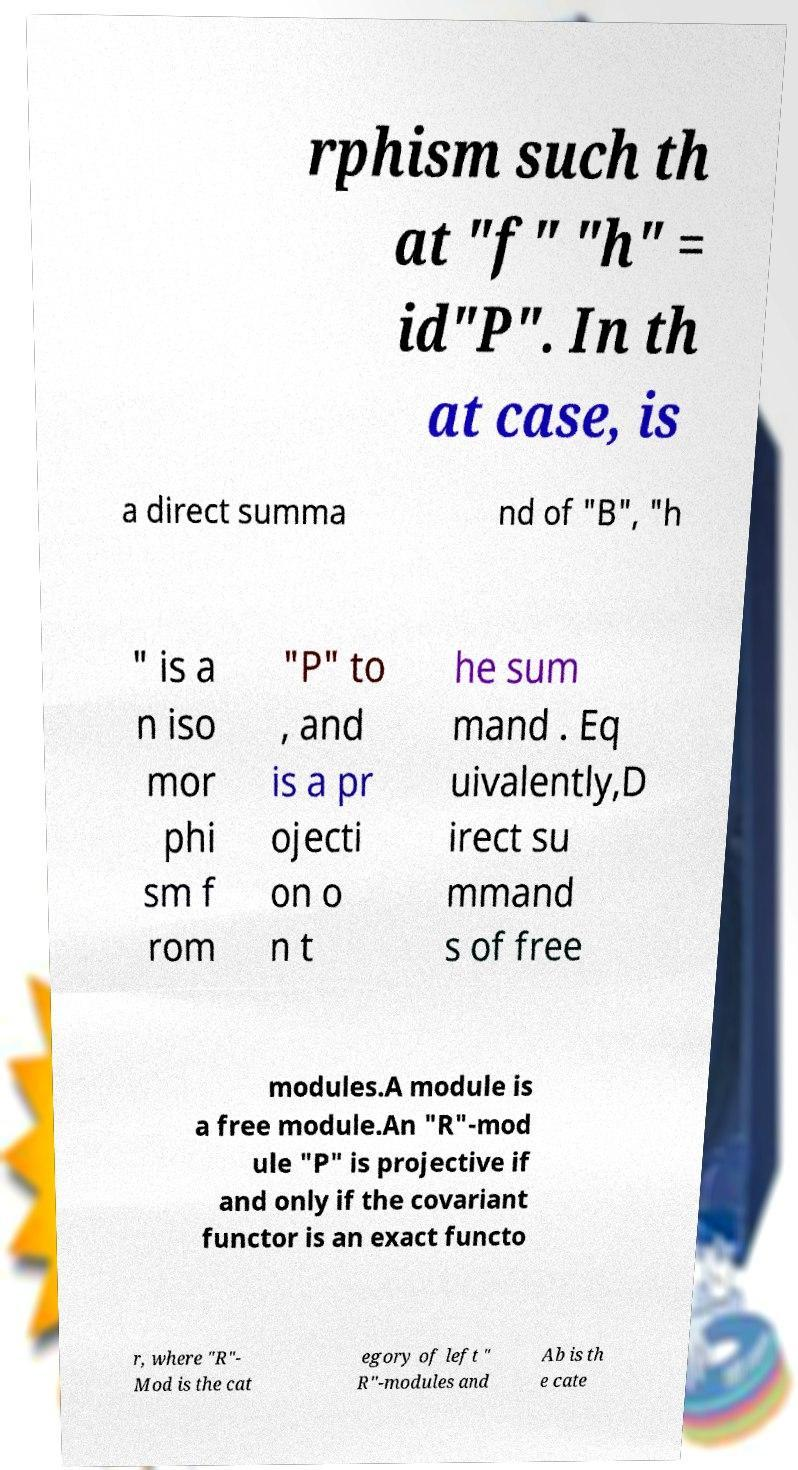There's text embedded in this image that I need extracted. Can you transcribe it verbatim? rphism such th at "f" "h" = id"P". In th at case, is a direct summa nd of "B", "h " is a n iso mor phi sm f rom "P" to , and is a pr ojecti on o n t he sum mand . Eq uivalently,D irect su mmand s of free modules.A module is a free module.An "R"-mod ule "P" is projective if and only if the covariant functor is an exact functo r, where "R"- Mod is the cat egory of left " R"-modules and Ab is th e cate 